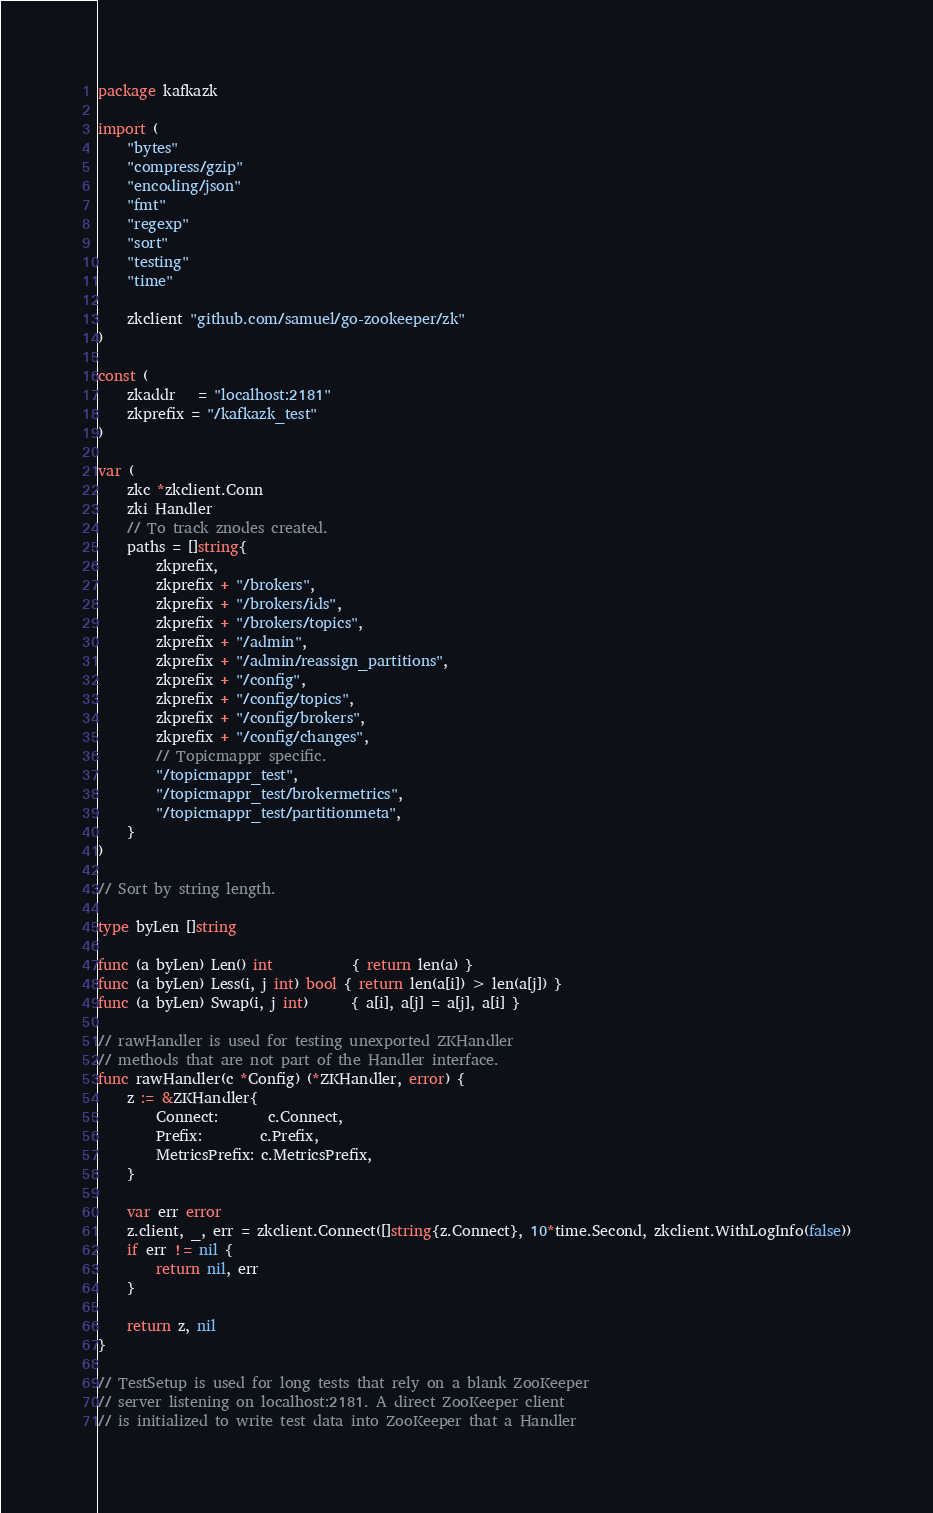<code> <loc_0><loc_0><loc_500><loc_500><_Go_>package kafkazk

import (
	"bytes"
	"compress/gzip"
	"encoding/json"
	"fmt"
	"regexp"
	"sort"
	"testing"
	"time"

	zkclient "github.com/samuel/go-zookeeper/zk"
)

const (
	zkaddr   = "localhost:2181"
	zkprefix = "/kafkazk_test"
)

var (
	zkc *zkclient.Conn
	zki Handler
	// To track znodes created.
	paths = []string{
		zkprefix,
		zkprefix + "/brokers",
		zkprefix + "/brokers/ids",
		zkprefix + "/brokers/topics",
		zkprefix + "/admin",
		zkprefix + "/admin/reassign_partitions",
		zkprefix + "/config",
		zkprefix + "/config/topics",
		zkprefix + "/config/brokers",
		zkprefix + "/config/changes",
		// Topicmappr specific.
		"/topicmappr_test",
		"/topicmappr_test/brokermetrics",
		"/topicmappr_test/partitionmeta",
	}
)

// Sort by string length.

type byLen []string

func (a byLen) Len() int           { return len(a) }
func (a byLen) Less(i, j int) bool { return len(a[i]) > len(a[j]) }
func (a byLen) Swap(i, j int)      { a[i], a[j] = a[j], a[i] }

// rawHandler is used for testing unexported ZKHandler
// methods that are not part of the Handler interface.
func rawHandler(c *Config) (*ZKHandler, error) {
	z := &ZKHandler{
		Connect:       c.Connect,
		Prefix:        c.Prefix,
		MetricsPrefix: c.MetricsPrefix,
	}

	var err error
	z.client, _, err = zkclient.Connect([]string{z.Connect}, 10*time.Second, zkclient.WithLogInfo(false))
	if err != nil {
		return nil, err
	}

	return z, nil
}

// TestSetup is used for long tests that rely on a blank ZooKeeper
// server listening on localhost:2181. A direct ZooKeeper client
// is initialized to write test data into ZooKeeper that a Handler</code> 